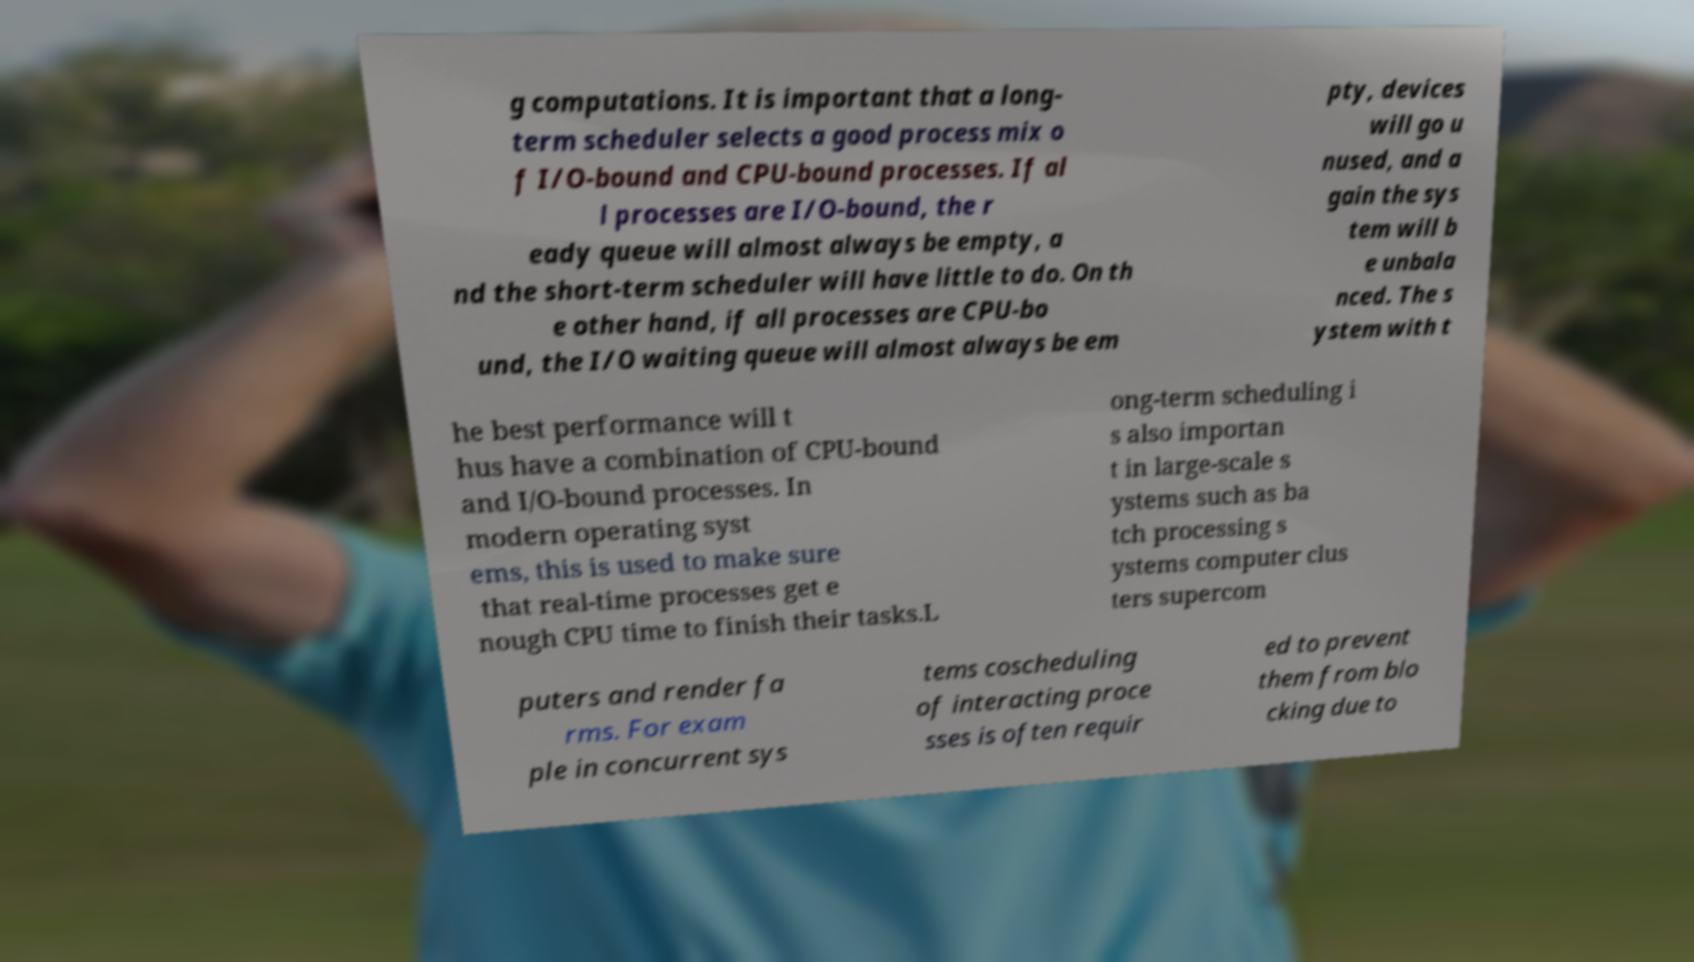Can you read and provide the text displayed in the image?This photo seems to have some interesting text. Can you extract and type it out for me? g computations. It is important that a long- term scheduler selects a good process mix o f I/O-bound and CPU-bound processes. If al l processes are I/O-bound, the r eady queue will almost always be empty, a nd the short-term scheduler will have little to do. On th e other hand, if all processes are CPU-bo und, the I/O waiting queue will almost always be em pty, devices will go u nused, and a gain the sys tem will b e unbala nced. The s ystem with t he best performance will t hus have a combination of CPU-bound and I/O-bound processes. In modern operating syst ems, this is used to make sure that real-time processes get e nough CPU time to finish their tasks.L ong-term scheduling i s also importan t in large-scale s ystems such as ba tch processing s ystems computer clus ters supercom puters and render fa rms. For exam ple in concurrent sys tems coscheduling of interacting proce sses is often requir ed to prevent them from blo cking due to 